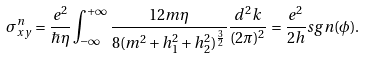Convert formula to latex. <formula><loc_0><loc_0><loc_500><loc_500>\sigma _ { x y } ^ { n } = \frac { e ^ { 2 } } { \hbar { \eta } } \int _ { - \infty } ^ { + \infty } \frac { 1 2 m \eta } { 8 ( m ^ { 2 } + h _ { 1 } ^ { 2 } + h _ { 2 } ^ { 2 } ) ^ { \frac { 3 } { 2 } } } \frac { d ^ { 2 } k } { ( 2 \pi ) ^ { 2 } } = \frac { e ^ { 2 } } { 2 h } s g n ( \phi ) .</formula> 